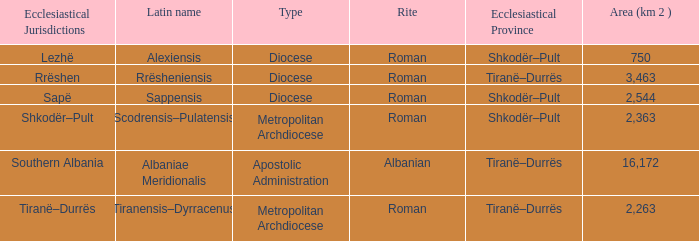What Area (km 2) is lowest with a type being Apostolic Administration? 16172.0. 